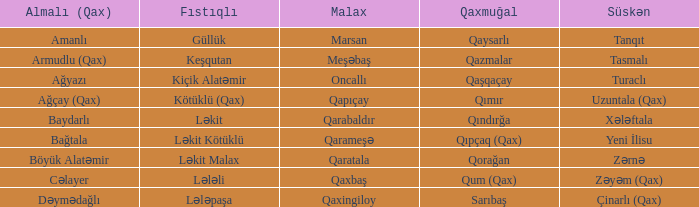What is the süskən village with a malax village forest head? Tasmalı. 